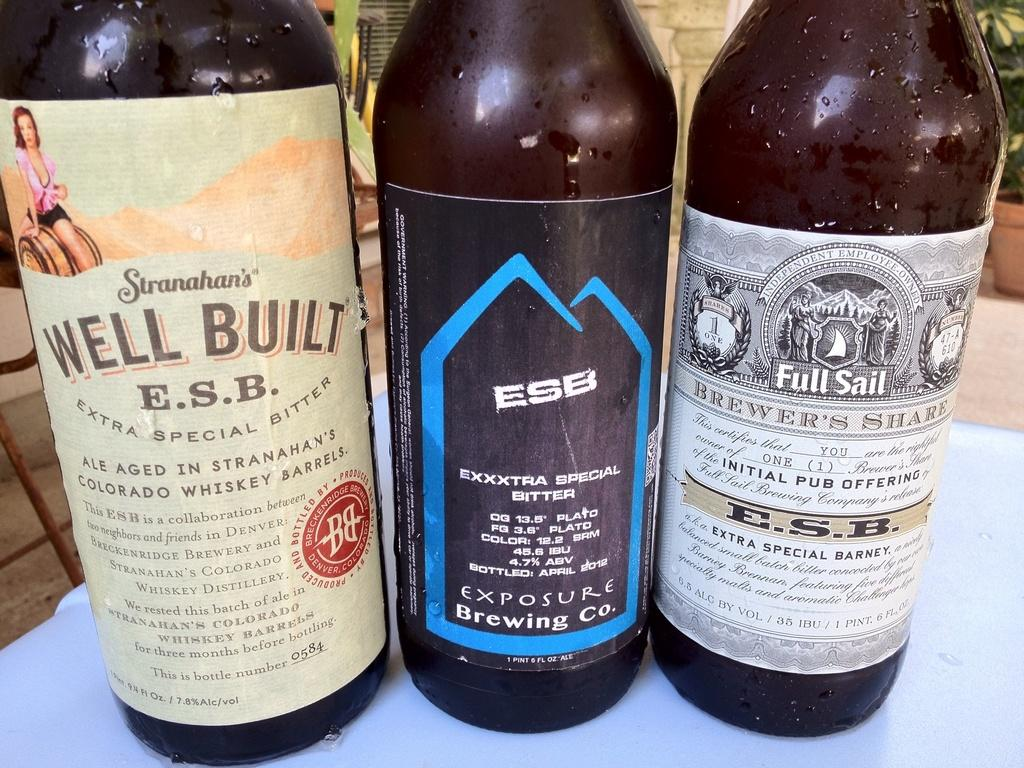<image>
Give a short and clear explanation of the subsequent image. Several different bottles have the ESB on the labels. 